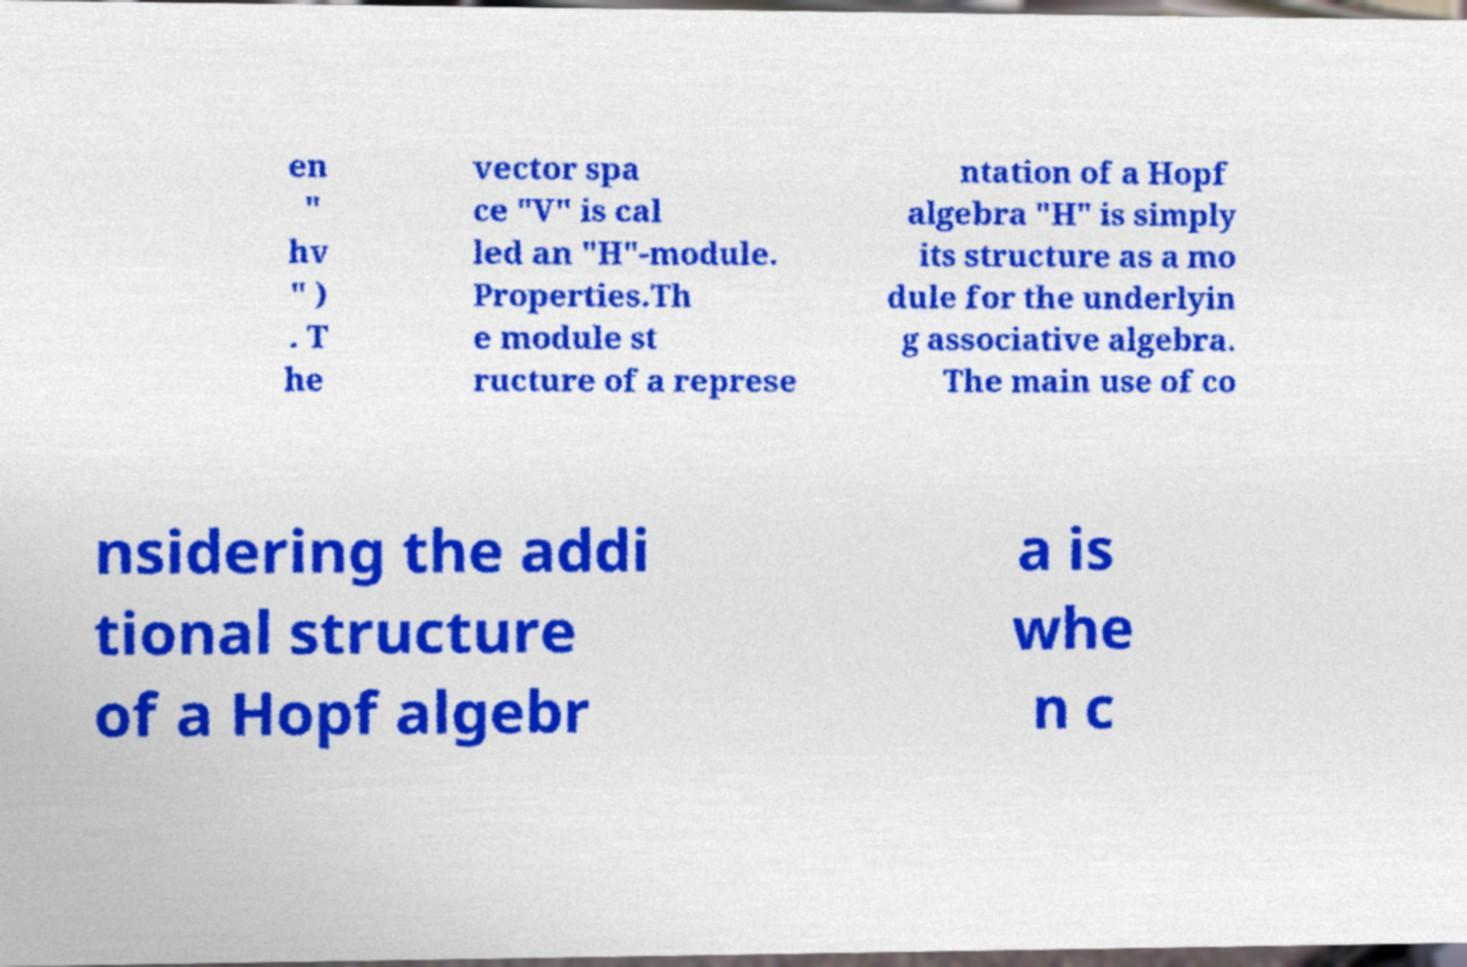I need the written content from this picture converted into text. Can you do that? en " hv " ) . T he vector spa ce "V" is cal led an "H"-module. Properties.Th e module st ructure of a represe ntation of a Hopf algebra "H" is simply its structure as a mo dule for the underlyin g associative algebra. The main use of co nsidering the addi tional structure of a Hopf algebr a is whe n c 